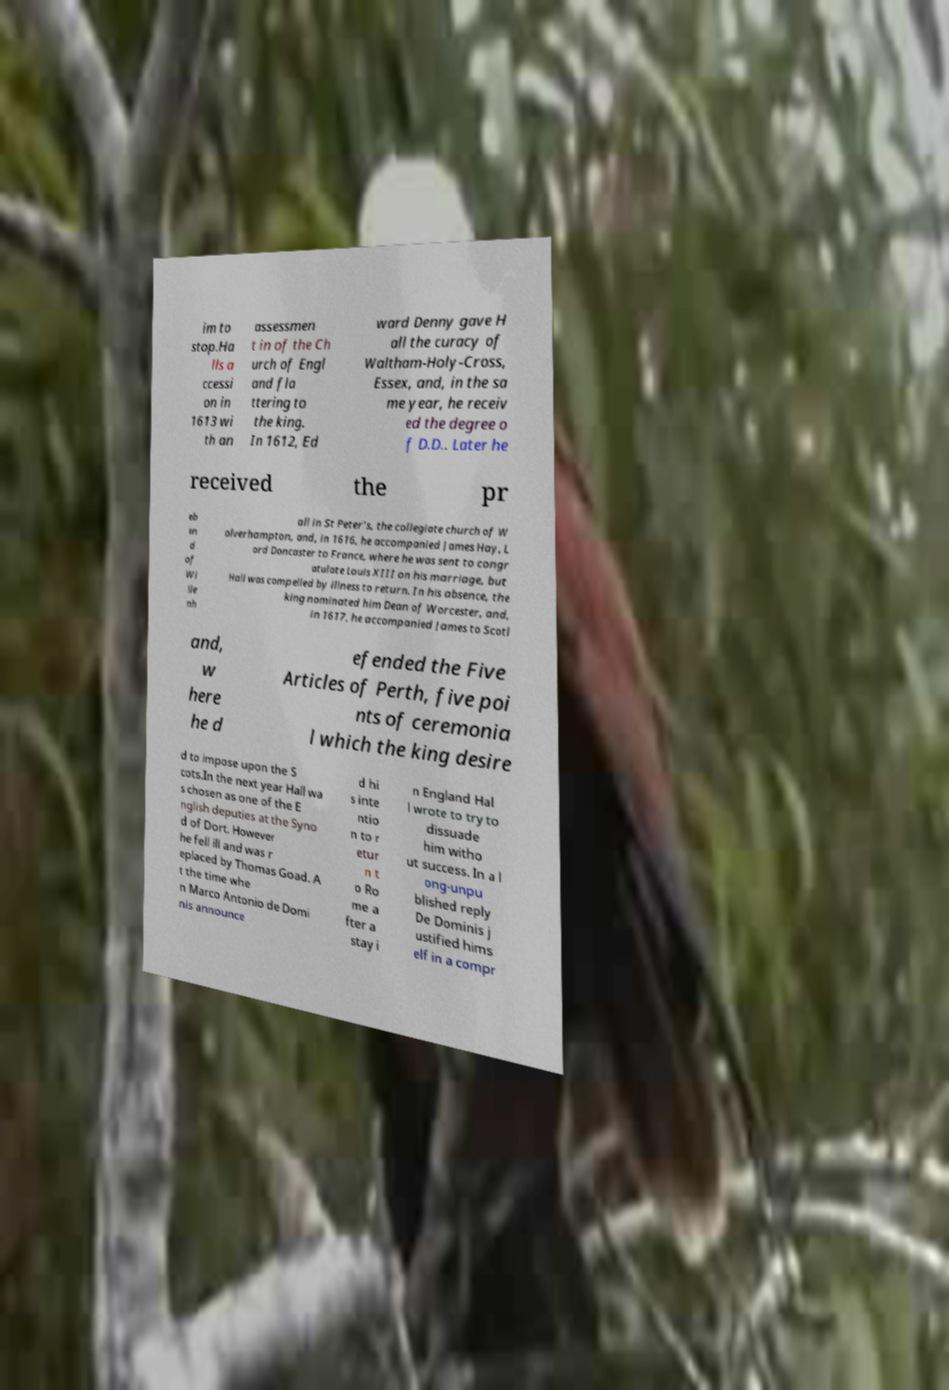Please identify and transcribe the text found in this image. im to stop.Ha lls a ccessi on in 1613 wi th an assessmen t in of the Ch urch of Engl and fla ttering to the king. In 1612, Ed ward Denny gave H all the curacy of Waltham-Holy-Cross, Essex, and, in the sa me year, he receiv ed the degree o f D.D.. Later he received the pr eb en d of Wi lle nh all in St Peter's, the collegiate church of W olverhampton, and, in 1616, he accompanied James Hay, L ord Doncaster to France, where he was sent to congr atulate Louis XIII on his marriage, but Hall was compelled by illness to return. In his absence, the king nominated him Dean of Worcester, and, in 1617, he accompanied James to Scotl and, w here he d efended the Five Articles of Perth, five poi nts of ceremonia l which the king desire d to impose upon the S cots.In the next year Hall wa s chosen as one of the E nglish deputies at the Syno d of Dort. However he fell ill and was r eplaced by Thomas Goad. A t the time whe n Marco Antonio de Domi nis announce d hi s inte ntio n to r etur n t o Ro me a fter a stay i n England Hal l wrote to try to dissuade him witho ut success. In a l ong-unpu blished reply De Dominis j ustified hims elf in a compr 